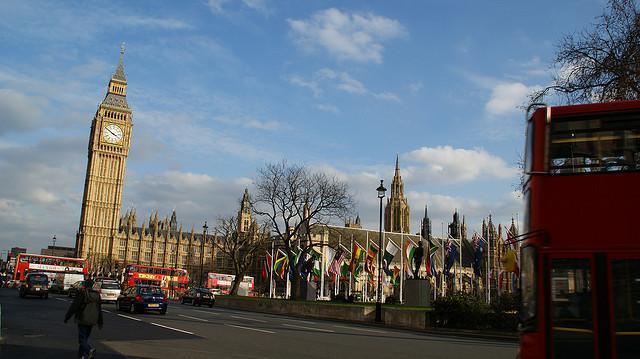How many double-decker buses do you see?
Give a very brief answer. 3. 